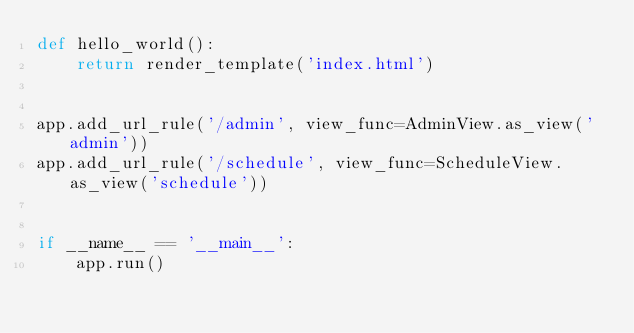Convert code to text. <code><loc_0><loc_0><loc_500><loc_500><_Python_>def hello_world():
    return render_template('index.html')


app.add_url_rule('/admin', view_func=AdminView.as_view('admin'))
app.add_url_rule('/schedule', view_func=ScheduleView.as_view('schedule'))


if __name__ == '__main__':
    app.run()
</code> 